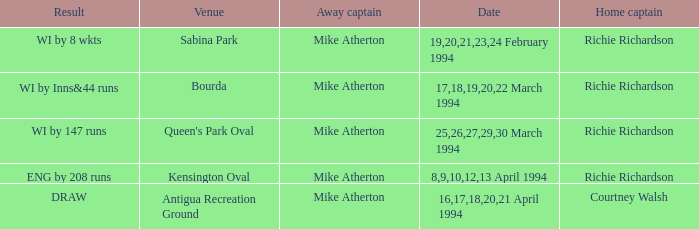What is the result of Courtney Walsh ? DRAW. 